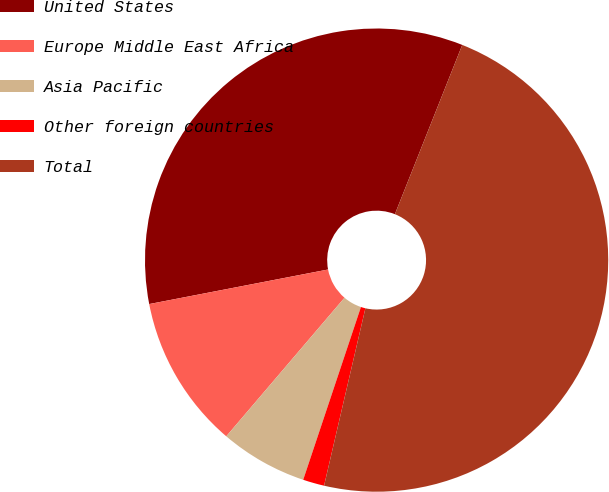<chart> <loc_0><loc_0><loc_500><loc_500><pie_chart><fcel>United States<fcel>Europe Middle East Africa<fcel>Asia Pacific<fcel>Other foreign countries<fcel>Total<nl><fcel>34.07%<fcel>10.72%<fcel>6.11%<fcel>1.49%<fcel>47.62%<nl></chart> 